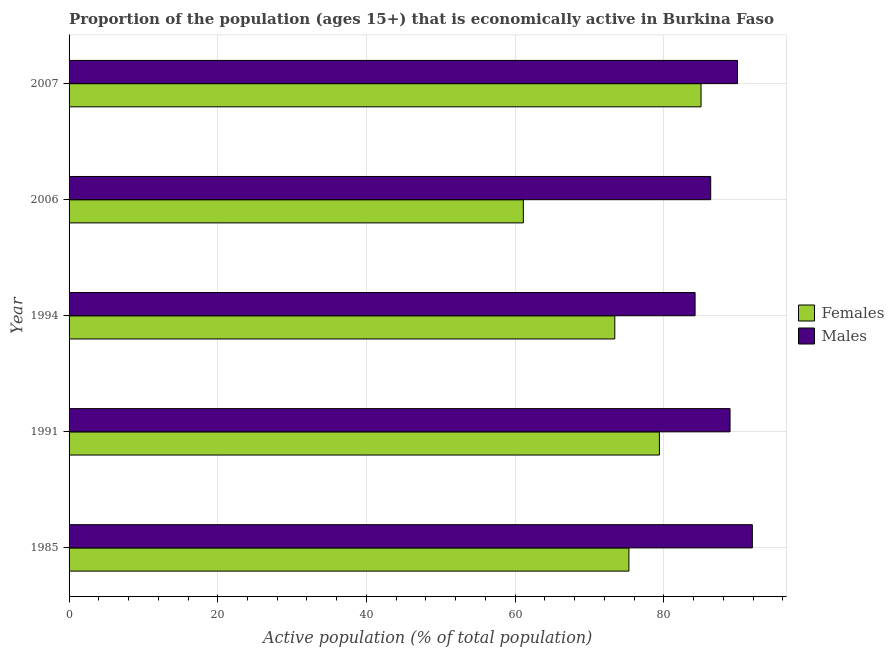How many different coloured bars are there?
Provide a succinct answer. 2. What is the label of the 1st group of bars from the top?
Provide a succinct answer. 2007. What is the percentage of economically active female population in 2007?
Your answer should be compact. 85. Across all years, what is the maximum percentage of economically active female population?
Give a very brief answer. 85. Across all years, what is the minimum percentage of economically active female population?
Offer a terse response. 61.1. In which year was the percentage of economically active male population minimum?
Your answer should be compact. 1994. What is the total percentage of economically active female population in the graph?
Your response must be concise. 374.2. What is the difference between the percentage of economically active female population in 2006 and the percentage of economically active male population in 1994?
Your answer should be compact. -23.1. What is the average percentage of economically active male population per year?
Provide a short and direct response. 88.24. In the year 1985, what is the difference between the percentage of economically active female population and percentage of economically active male population?
Your response must be concise. -16.6. What is the ratio of the percentage of economically active female population in 1994 to that in 2007?
Give a very brief answer. 0.86. Is the percentage of economically active female population in 1985 less than that in 1991?
Offer a terse response. Yes. What is the difference between the highest and the lowest percentage of economically active female population?
Your answer should be compact. 23.9. What does the 1st bar from the top in 1991 represents?
Offer a terse response. Males. What does the 1st bar from the bottom in 1991 represents?
Offer a terse response. Females. How many bars are there?
Your answer should be compact. 10. Are all the bars in the graph horizontal?
Ensure brevity in your answer.  Yes. How many years are there in the graph?
Ensure brevity in your answer.  5. Are the values on the major ticks of X-axis written in scientific E-notation?
Keep it short and to the point. No. Does the graph contain any zero values?
Your answer should be very brief. No. Does the graph contain grids?
Your answer should be compact. Yes. Where does the legend appear in the graph?
Provide a succinct answer. Center right. What is the title of the graph?
Provide a succinct answer. Proportion of the population (ages 15+) that is economically active in Burkina Faso. What is the label or title of the X-axis?
Your response must be concise. Active population (% of total population). What is the Active population (% of total population) of Females in 1985?
Your answer should be very brief. 75.3. What is the Active population (% of total population) in Males in 1985?
Ensure brevity in your answer.  91.9. What is the Active population (% of total population) in Females in 1991?
Keep it short and to the point. 79.4. What is the Active population (% of total population) in Males in 1991?
Give a very brief answer. 88.9. What is the Active population (% of total population) in Females in 1994?
Keep it short and to the point. 73.4. What is the Active population (% of total population) of Males in 1994?
Keep it short and to the point. 84.2. What is the Active population (% of total population) in Females in 2006?
Provide a succinct answer. 61.1. What is the Active population (% of total population) of Males in 2006?
Your answer should be compact. 86.3. What is the Active population (% of total population) of Males in 2007?
Offer a terse response. 89.9. Across all years, what is the maximum Active population (% of total population) in Males?
Your response must be concise. 91.9. Across all years, what is the minimum Active population (% of total population) of Females?
Offer a terse response. 61.1. Across all years, what is the minimum Active population (% of total population) in Males?
Your response must be concise. 84.2. What is the total Active population (% of total population) of Females in the graph?
Keep it short and to the point. 374.2. What is the total Active population (% of total population) of Males in the graph?
Keep it short and to the point. 441.2. What is the difference between the Active population (% of total population) in Males in 1985 and that in 1991?
Make the answer very short. 3. What is the difference between the Active population (% of total population) in Males in 1985 and that in 1994?
Your response must be concise. 7.7. What is the difference between the Active population (% of total population) of Males in 1985 and that in 2006?
Your answer should be compact. 5.6. What is the difference between the Active population (% of total population) in Females in 1985 and that in 2007?
Ensure brevity in your answer.  -9.7. What is the difference between the Active population (% of total population) in Males in 1985 and that in 2007?
Ensure brevity in your answer.  2. What is the difference between the Active population (% of total population) of Males in 1991 and that in 1994?
Offer a terse response. 4.7. What is the difference between the Active population (% of total population) of Males in 1994 and that in 2007?
Make the answer very short. -5.7. What is the difference between the Active population (% of total population) of Females in 2006 and that in 2007?
Keep it short and to the point. -23.9. What is the difference between the Active population (% of total population) of Females in 1985 and the Active population (% of total population) of Males in 2007?
Offer a terse response. -14.6. What is the difference between the Active population (% of total population) in Females in 1994 and the Active population (% of total population) in Males in 2007?
Your answer should be compact. -16.5. What is the difference between the Active population (% of total population) of Females in 2006 and the Active population (% of total population) of Males in 2007?
Ensure brevity in your answer.  -28.8. What is the average Active population (% of total population) of Females per year?
Keep it short and to the point. 74.84. What is the average Active population (% of total population) of Males per year?
Offer a terse response. 88.24. In the year 1985, what is the difference between the Active population (% of total population) of Females and Active population (% of total population) of Males?
Your answer should be compact. -16.6. In the year 1991, what is the difference between the Active population (% of total population) in Females and Active population (% of total population) in Males?
Your answer should be compact. -9.5. In the year 2006, what is the difference between the Active population (% of total population) in Females and Active population (% of total population) in Males?
Your answer should be very brief. -25.2. What is the ratio of the Active population (% of total population) of Females in 1985 to that in 1991?
Give a very brief answer. 0.95. What is the ratio of the Active population (% of total population) of Males in 1985 to that in 1991?
Give a very brief answer. 1.03. What is the ratio of the Active population (% of total population) in Females in 1985 to that in 1994?
Give a very brief answer. 1.03. What is the ratio of the Active population (% of total population) of Males in 1985 to that in 1994?
Offer a terse response. 1.09. What is the ratio of the Active population (% of total population) of Females in 1985 to that in 2006?
Provide a short and direct response. 1.23. What is the ratio of the Active population (% of total population) of Males in 1985 to that in 2006?
Your answer should be very brief. 1.06. What is the ratio of the Active population (% of total population) of Females in 1985 to that in 2007?
Give a very brief answer. 0.89. What is the ratio of the Active population (% of total population) of Males in 1985 to that in 2007?
Offer a very short reply. 1.02. What is the ratio of the Active population (% of total population) of Females in 1991 to that in 1994?
Your answer should be compact. 1.08. What is the ratio of the Active population (% of total population) of Males in 1991 to that in 1994?
Offer a very short reply. 1.06. What is the ratio of the Active population (% of total population) in Females in 1991 to that in 2006?
Your answer should be compact. 1.3. What is the ratio of the Active population (% of total population) of Males in 1991 to that in 2006?
Your answer should be compact. 1.03. What is the ratio of the Active population (% of total population) of Females in 1991 to that in 2007?
Offer a terse response. 0.93. What is the ratio of the Active population (% of total population) of Males in 1991 to that in 2007?
Offer a terse response. 0.99. What is the ratio of the Active population (% of total population) of Females in 1994 to that in 2006?
Your answer should be compact. 1.2. What is the ratio of the Active population (% of total population) of Males in 1994 to that in 2006?
Ensure brevity in your answer.  0.98. What is the ratio of the Active population (% of total population) of Females in 1994 to that in 2007?
Ensure brevity in your answer.  0.86. What is the ratio of the Active population (% of total population) in Males in 1994 to that in 2007?
Offer a very short reply. 0.94. What is the ratio of the Active population (% of total population) of Females in 2006 to that in 2007?
Provide a succinct answer. 0.72. What is the difference between the highest and the second highest Active population (% of total population) of Males?
Make the answer very short. 2. What is the difference between the highest and the lowest Active population (% of total population) of Females?
Your answer should be very brief. 23.9. What is the difference between the highest and the lowest Active population (% of total population) in Males?
Ensure brevity in your answer.  7.7. 